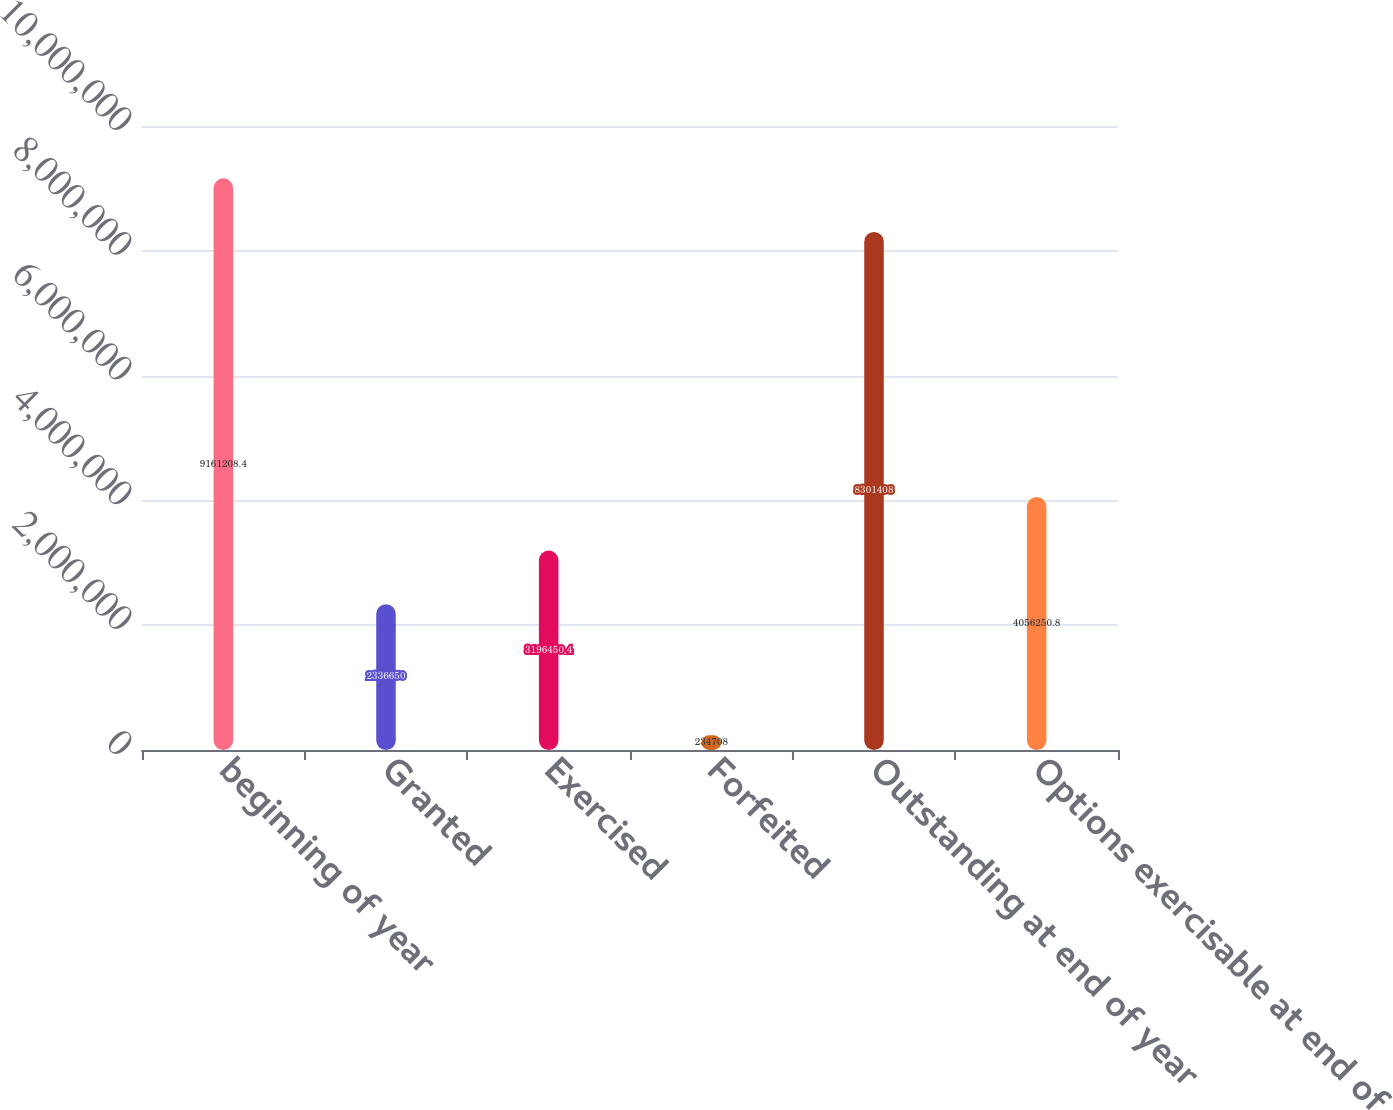Convert chart. <chart><loc_0><loc_0><loc_500><loc_500><bar_chart><fcel>beginning of year<fcel>Granted<fcel>Exercised<fcel>Forfeited<fcel>Outstanding at end of year<fcel>Options exercisable at end of<nl><fcel>9.16121e+06<fcel>2.33665e+06<fcel>3.19645e+06<fcel>234708<fcel>8.30141e+06<fcel>4.05625e+06<nl></chart> 